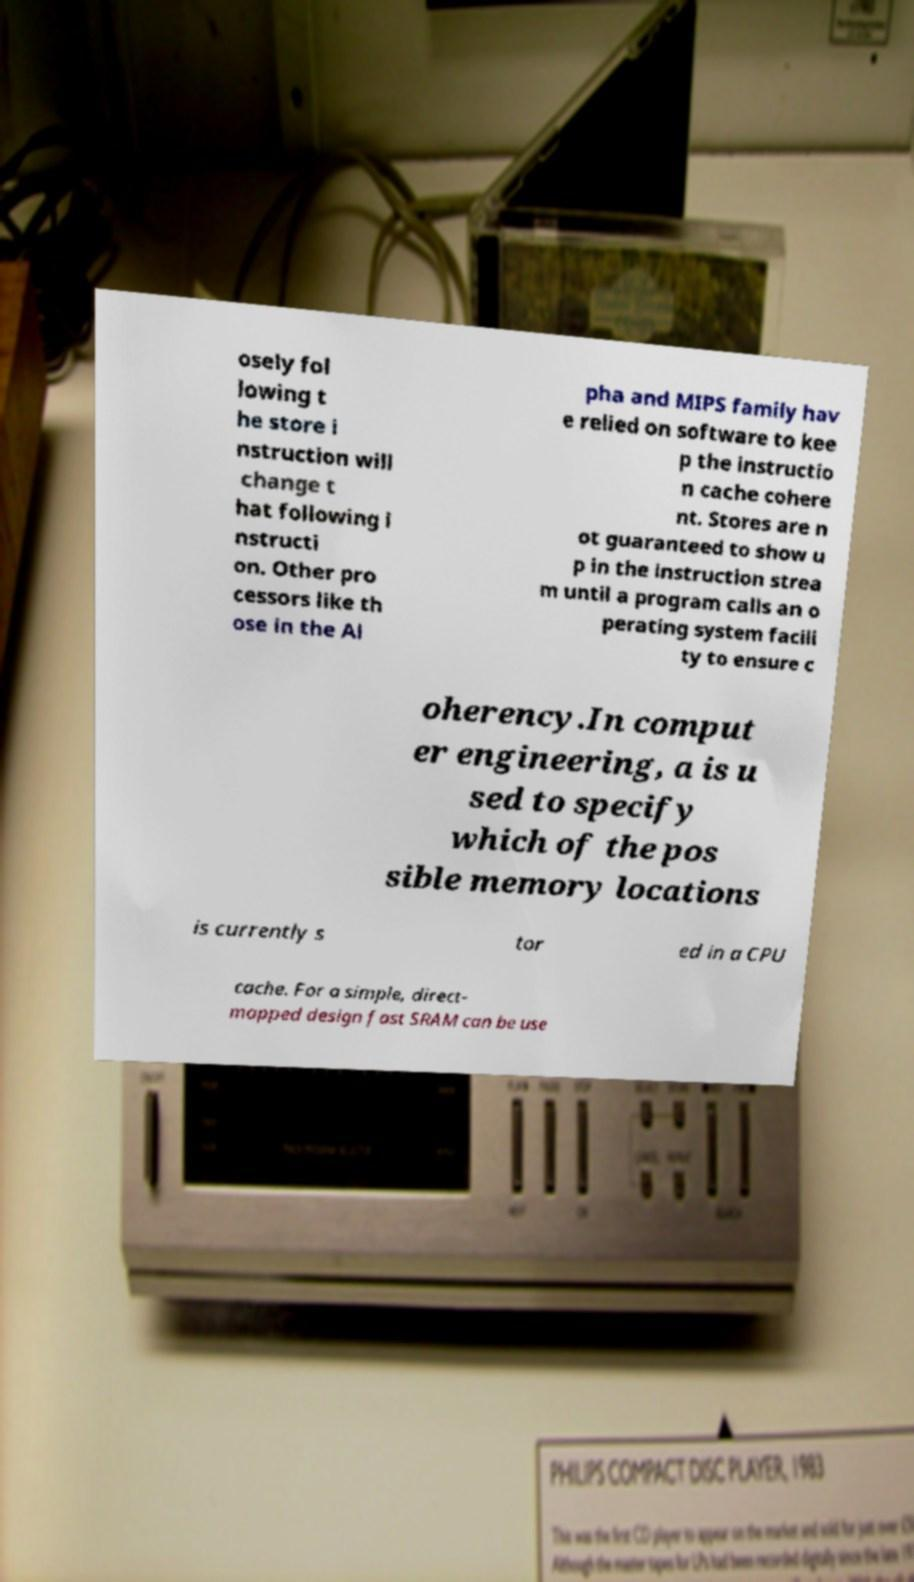Please read and relay the text visible in this image. What does it say? osely fol lowing t he store i nstruction will change t hat following i nstructi on. Other pro cessors like th ose in the Al pha and MIPS family hav e relied on software to kee p the instructio n cache cohere nt. Stores are n ot guaranteed to show u p in the instruction strea m until a program calls an o perating system facili ty to ensure c oherency.In comput er engineering, a is u sed to specify which of the pos sible memory locations is currently s tor ed in a CPU cache. For a simple, direct- mapped design fast SRAM can be use 